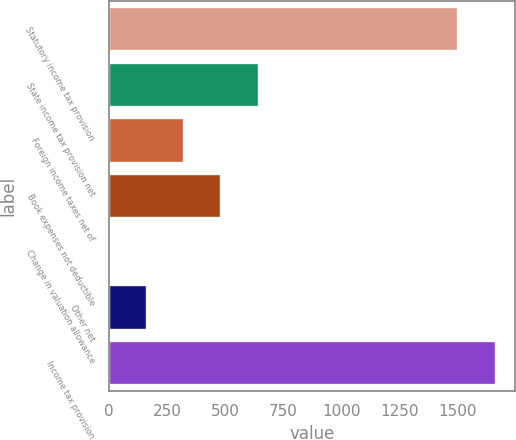<chart> <loc_0><loc_0><loc_500><loc_500><bar_chart><fcel>Statutory income tax provision<fcel>State income tax provision net<fcel>Foreign income taxes net of<fcel>Book expenses not deductible<fcel>Change in valuation allowance<fcel>Other net<fcel>Income tax provision<nl><fcel>1504<fcel>643.4<fcel>322.2<fcel>482.8<fcel>1<fcel>161.6<fcel>1664.6<nl></chart> 